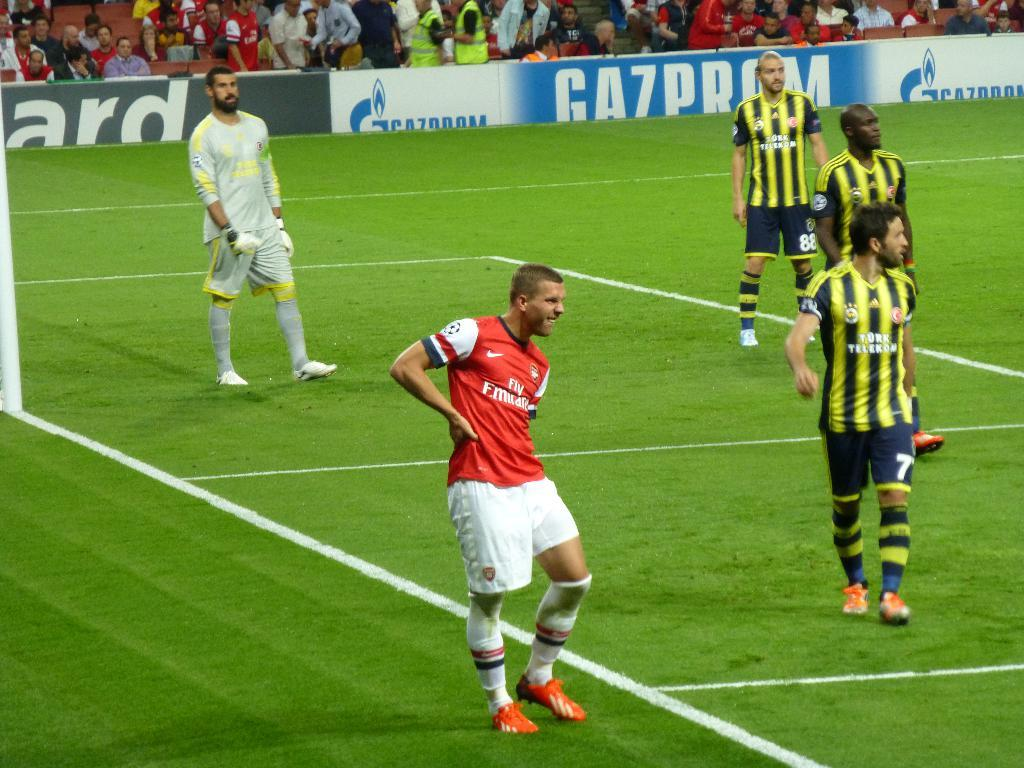<image>
Render a clear and concise summary of the photo. Soccer players standing on a field in front of an ad that says CA7PROM 